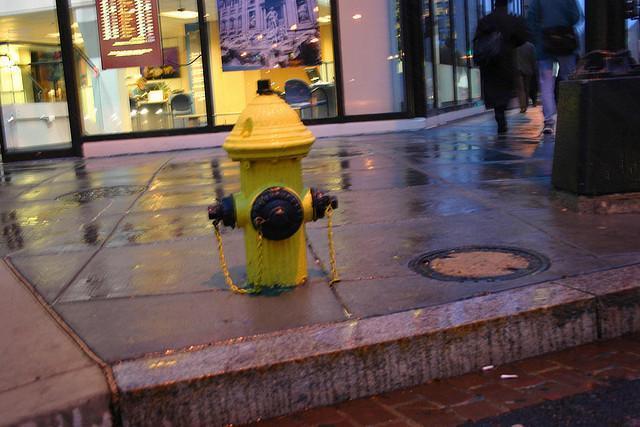How many people can you see?
Give a very brief answer. 2. 